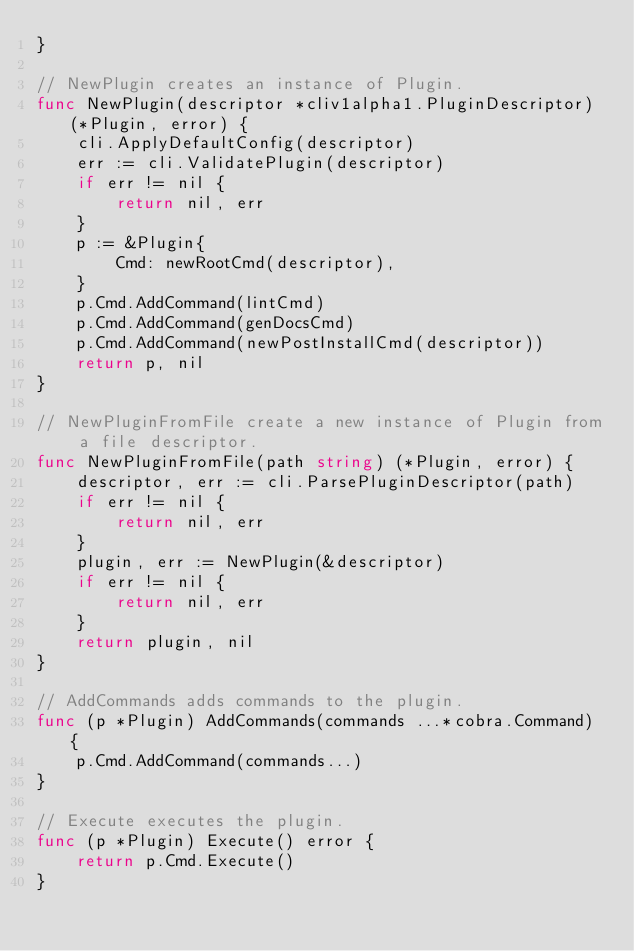Convert code to text. <code><loc_0><loc_0><loc_500><loc_500><_Go_>}

// NewPlugin creates an instance of Plugin.
func NewPlugin(descriptor *cliv1alpha1.PluginDescriptor) (*Plugin, error) {
	cli.ApplyDefaultConfig(descriptor)
	err := cli.ValidatePlugin(descriptor)
	if err != nil {
		return nil, err
	}
	p := &Plugin{
		Cmd: newRootCmd(descriptor),
	}
	p.Cmd.AddCommand(lintCmd)
	p.Cmd.AddCommand(genDocsCmd)
	p.Cmd.AddCommand(newPostInstallCmd(descriptor))
	return p, nil
}

// NewPluginFromFile create a new instance of Plugin from a file descriptor.
func NewPluginFromFile(path string) (*Plugin, error) {
	descriptor, err := cli.ParsePluginDescriptor(path)
	if err != nil {
		return nil, err
	}
	plugin, err := NewPlugin(&descriptor)
	if err != nil {
		return nil, err
	}
	return plugin, nil
}

// AddCommands adds commands to the plugin.
func (p *Plugin) AddCommands(commands ...*cobra.Command) {
	p.Cmd.AddCommand(commands...)
}

// Execute executes the plugin.
func (p *Plugin) Execute() error {
	return p.Cmd.Execute()
}
</code> 